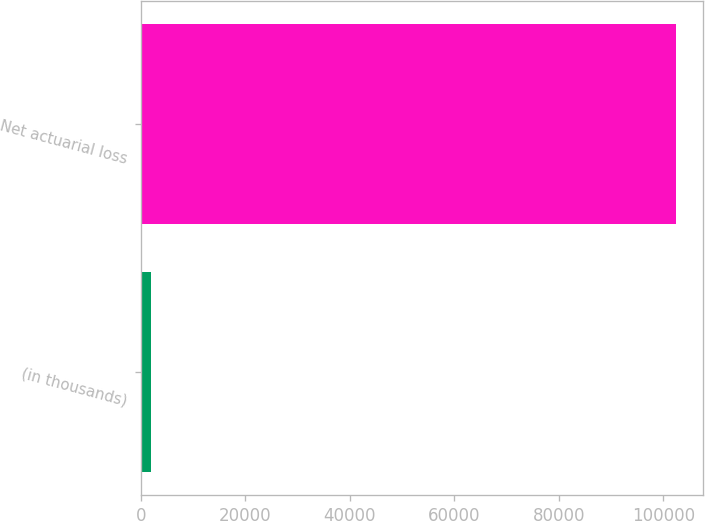Convert chart. <chart><loc_0><loc_0><loc_500><loc_500><bar_chart><fcel>(in thousands)<fcel>Net actuarial loss<nl><fcel>2012<fcel>102419<nl></chart> 